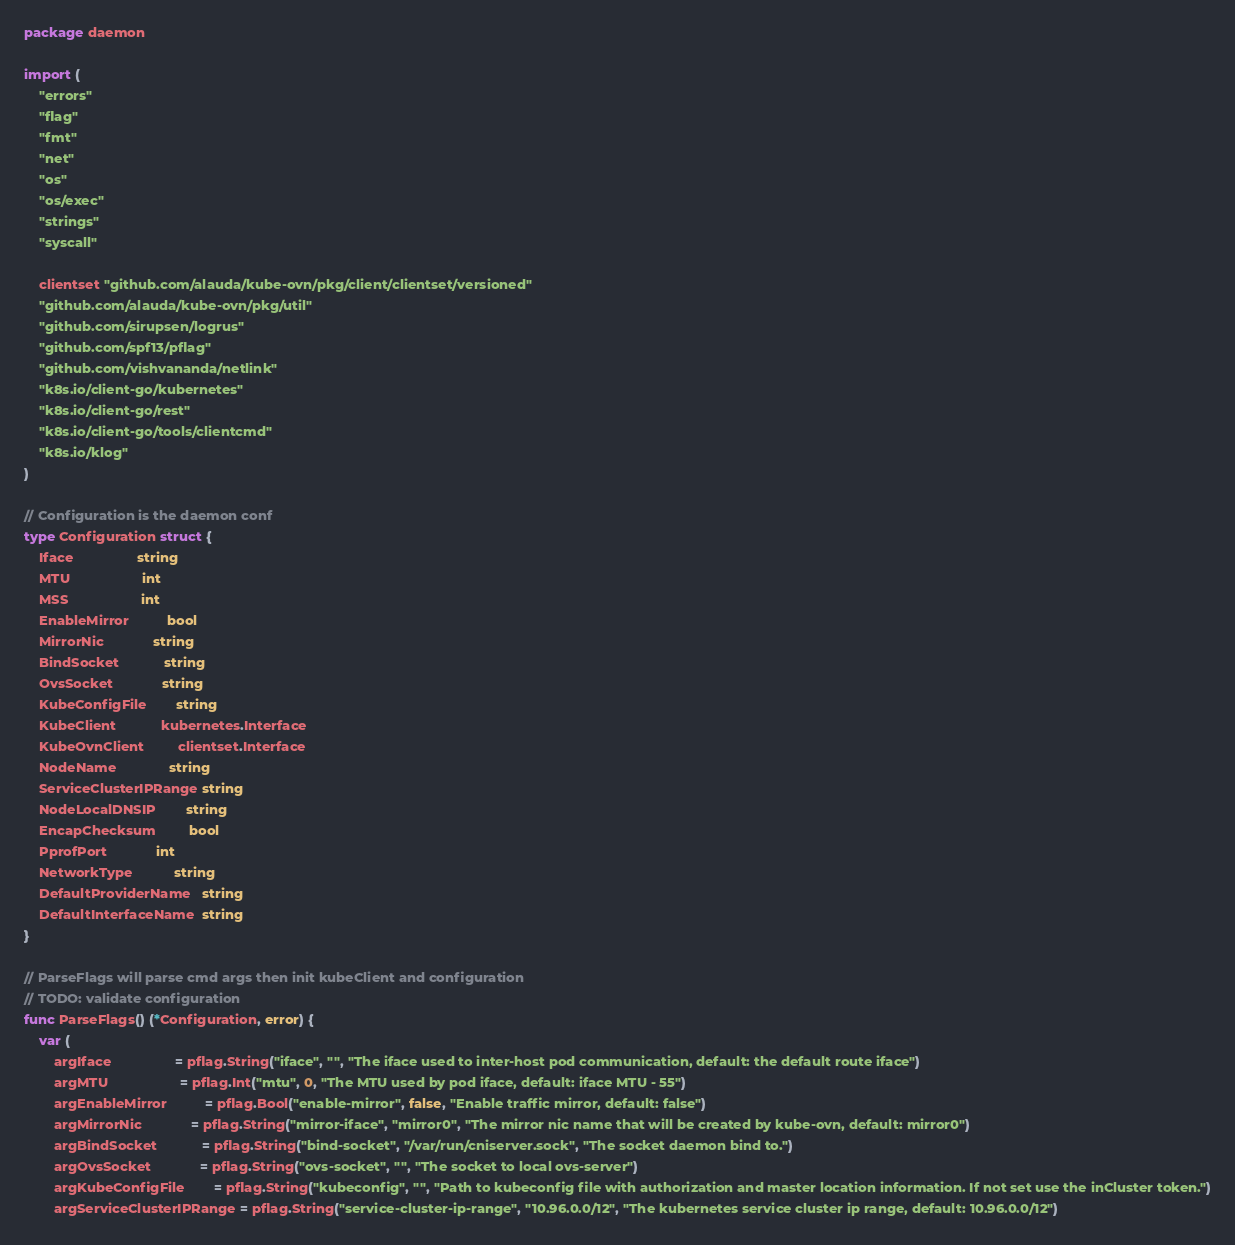<code> <loc_0><loc_0><loc_500><loc_500><_Go_>package daemon

import (
	"errors"
	"flag"
	"fmt"
	"net"
	"os"
	"os/exec"
	"strings"
	"syscall"

	clientset "github.com/alauda/kube-ovn/pkg/client/clientset/versioned"
	"github.com/alauda/kube-ovn/pkg/util"
	"github.com/sirupsen/logrus"
	"github.com/spf13/pflag"
	"github.com/vishvananda/netlink"
	"k8s.io/client-go/kubernetes"
	"k8s.io/client-go/rest"
	"k8s.io/client-go/tools/clientcmd"
	"k8s.io/klog"
)

// Configuration is the daemon conf
type Configuration struct {
	Iface                 string
	MTU                   int
	MSS                   int
	EnableMirror          bool
	MirrorNic             string
	BindSocket            string
	OvsSocket             string
	KubeConfigFile        string
	KubeClient            kubernetes.Interface
	KubeOvnClient         clientset.Interface
	NodeName              string
	ServiceClusterIPRange string
	NodeLocalDNSIP        string
	EncapChecksum         bool
	PprofPort             int
	NetworkType           string
	DefaultProviderName   string
	DefaultInterfaceName  string
}

// ParseFlags will parse cmd args then init kubeClient and configuration
// TODO: validate configuration
func ParseFlags() (*Configuration, error) {
	var (
		argIface                 = pflag.String("iface", "", "The iface used to inter-host pod communication, default: the default route iface")
		argMTU                   = pflag.Int("mtu", 0, "The MTU used by pod iface, default: iface MTU - 55")
		argEnableMirror          = pflag.Bool("enable-mirror", false, "Enable traffic mirror, default: false")
		argMirrorNic             = pflag.String("mirror-iface", "mirror0", "The mirror nic name that will be created by kube-ovn, default: mirror0")
		argBindSocket            = pflag.String("bind-socket", "/var/run/cniserver.sock", "The socket daemon bind to.")
		argOvsSocket             = pflag.String("ovs-socket", "", "The socket to local ovs-server")
		argKubeConfigFile        = pflag.String("kubeconfig", "", "Path to kubeconfig file with authorization and master location information. If not set use the inCluster token.")
		argServiceClusterIPRange = pflag.String("service-cluster-ip-range", "10.96.0.0/12", "The kubernetes service cluster ip range, default: 10.96.0.0/12")</code> 